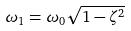<formula> <loc_0><loc_0><loc_500><loc_500>\omega _ { 1 } = \omega _ { 0 } \sqrt { 1 - \zeta ^ { 2 } }</formula> 